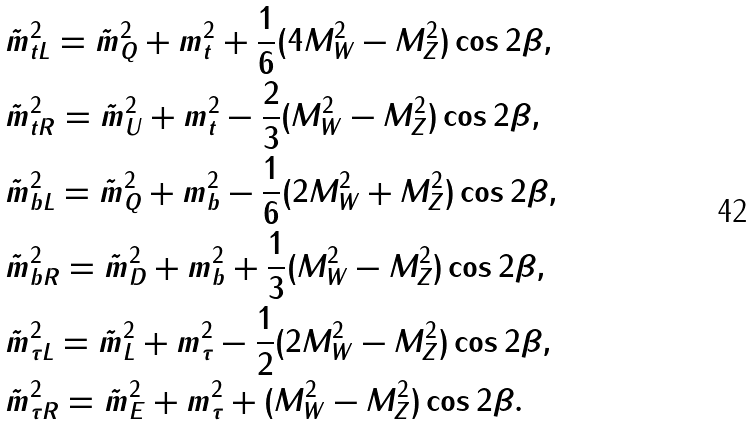<formula> <loc_0><loc_0><loc_500><loc_500>& \tilde { m } _ { t L } ^ { 2 } = \tilde { m } _ { Q } ^ { 2 } + m _ { t } ^ { 2 } + \frac { 1 } { 6 } ( 4 M _ { W } ^ { 2 } - M _ { Z } ^ { 2 } ) \cos 2 \beta , \\ & \tilde { m } _ { t R } ^ { 2 } = \tilde { m } _ { U } ^ { 2 } + m _ { t } ^ { 2 } - \frac { 2 } { 3 } ( M _ { W } ^ { 2 } - M _ { Z } ^ { 2 } ) \cos 2 \beta , \\ & \tilde { m } _ { b L } ^ { 2 } = \tilde { m } _ { Q } ^ { 2 } + m _ { b } ^ { 2 } - \frac { 1 } { 6 } ( 2 M _ { W } ^ { 2 } + M _ { Z } ^ { 2 } ) \cos 2 \beta , \\ & \tilde { m } _ { b R } ^ { 2 } = \tilde { m } _ { D } ^ { 2 } + m _ { b } ^ { 2 } + \frac { 1 } { 3 } ( M _ { W } ^ { 2 } - M _ { Z } ^ { 2 } ) \cos 2 \beta , \\ & \tilde { m } _ { \tau L } ^ { 2 } = \tilde { m } _ { L } ^ { 2 } + m _ { \tau } ^ { 2 } - \frac { 1 } { 2 } ( 2 M _ { W } ^ { 2 } - M _ { Z } ^ { 2 } ) \cos 2 \beta , \\ & \tilde { m } _ { \tau R } ^ { 2 } = \tilde { m } _ { E } ^ { 2 } + m _ { \tau } ^ { 2 } + ( M _ { W } ^ { 2 } - M _ { Z } ^ { 2 } ) \cos 2 \beta .</formula> 